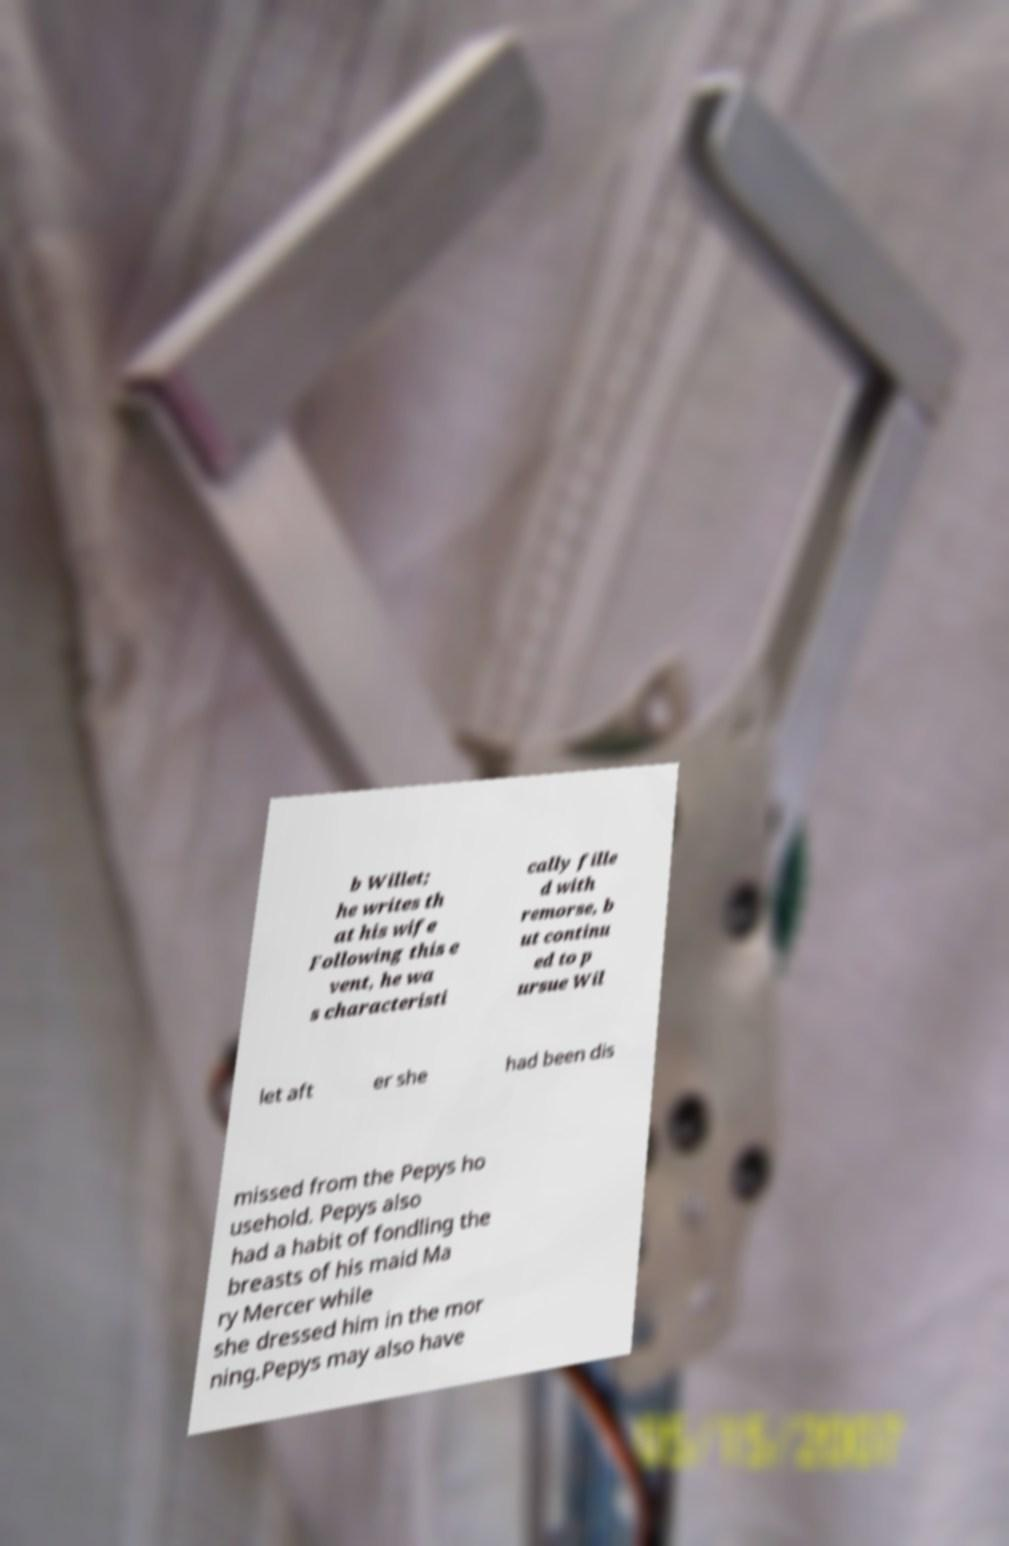Can you read and provide the text displayed in the image?This photo seems to have some interesting text. Can you extract and type it out for me? b Willet; he writes th at his wife Following this e vent, he wa s characteristi cally fille d with remorse, b ut continu ed to p ursue Wil let aft er she had been dis missed from the Pepys ho usehold. Pepys also had a habit of fondling the breasts of his maid Ma ry Mercer while she dressed him in the mor ning.Pepys may also have 